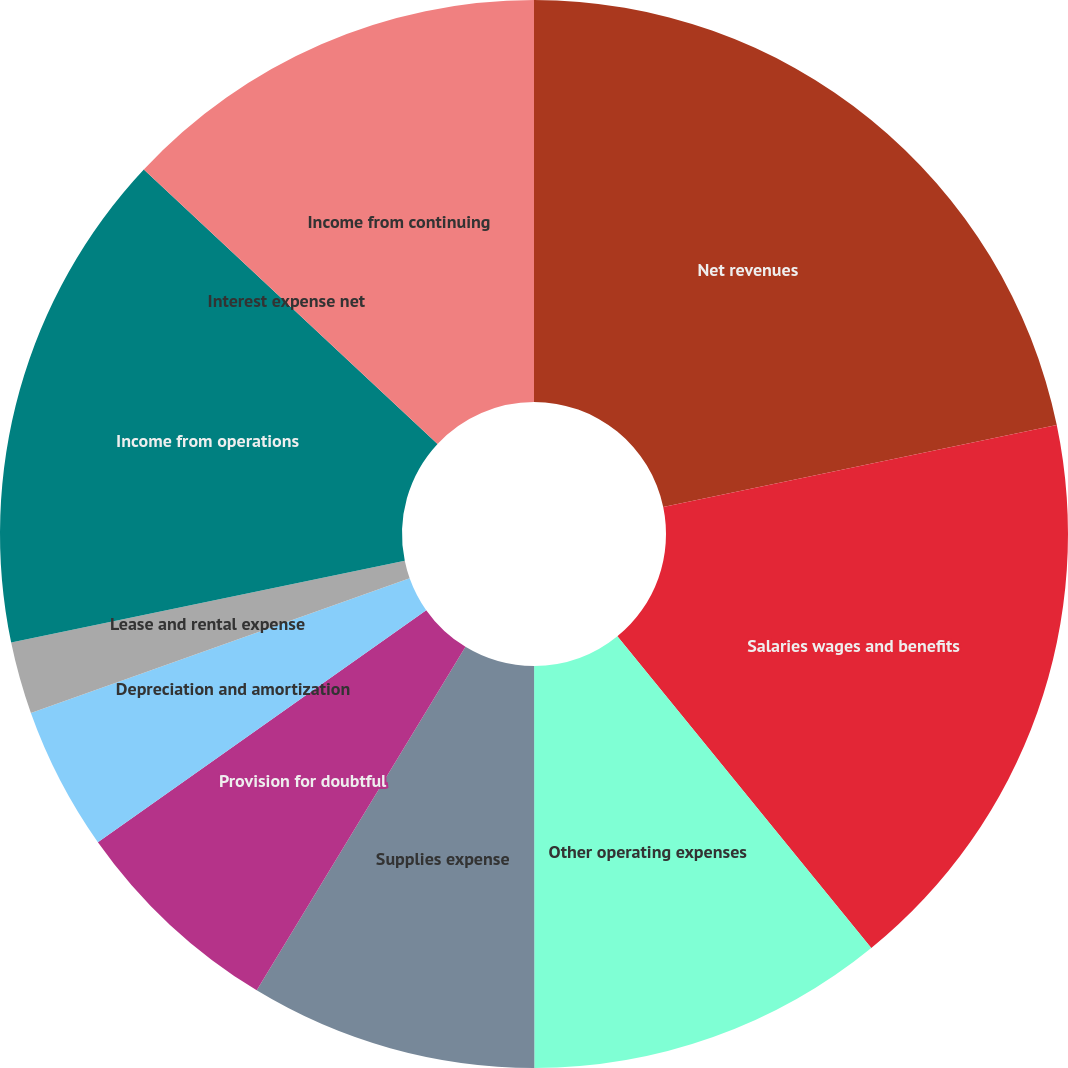Convert chart to OTSL. <chart><loc_0><loc_0><loc_500><loc_500><pie_chart><fcel>Net revenues<fcel>Salaries wages and benefits<fcel>Other operating expenses<fcel>Supplies expense<fcel>Provision for doubtful<fcel>Depreciation and amortization<fcel>Lease and rental expense<fcel>Income from operations<fcel>Interest expense net<fcel>Income from continuing<nl><fcel>21.73%<fcel>17.39%<fcel>10.87%<fcel>8.7%<fcel>6.52%<fcel>4.35%<fcel>2.18%<fcel>15.22%<fcel>0.0%<fcel>13.04%<nl></chart> 